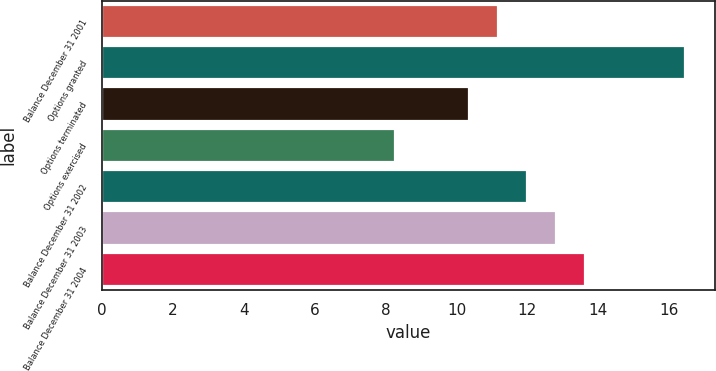<chart> <loc_0><loc_0><loc_500><loc_500><bar_chart><fcel>Balance December 31 2001<fcel>Options granted<fcel>Options terminated<fcel>Options exercised<fcel>Balance December 31 2002<fcel>Balance December 31 2003<fcel>Balance December 31 2004<nl><fcel>11.18<fcel>16.46<fcel>10.36<fcel>8.26<fcel>12<fcel>12.82<fcel>13.64<nl></chart> 